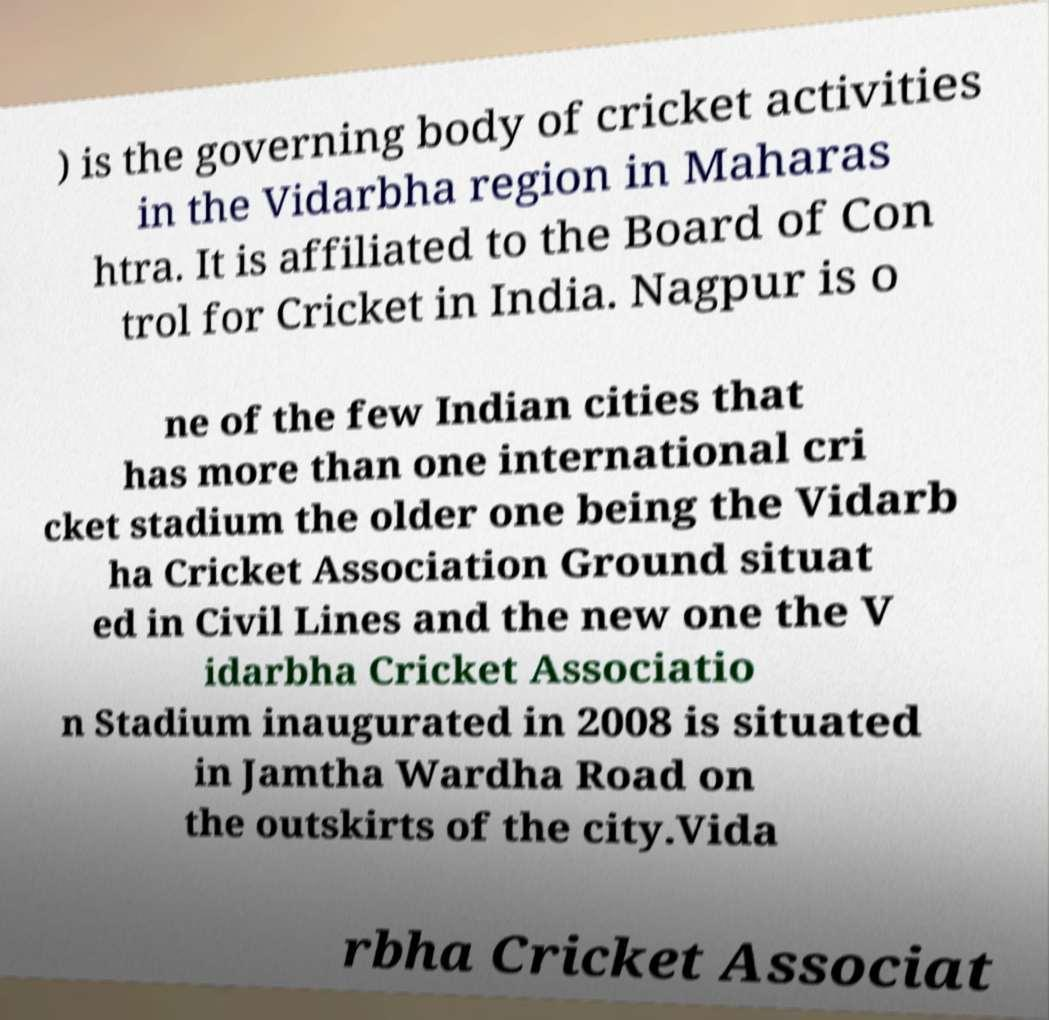Could you assist in decoding the text presented in this image and type it out clearly? ) is the governing body of cricket activities in the Vidarbha region in Maharas htra. It is affiliated to the Board of Con trol for Cricket in India. Nagpur is o ne of the few Indian cities that has more than one international cri cket stadium the older one being the Vidarb ha Cricket Association Ground situat ed in Civil Lines and the new one the V idarbha Cricket Associatio n Stadium inaugurated in 2008 is situated in Jamtha Wardha Road on the outskirts of the city.Vida rbha Cricket Associat 